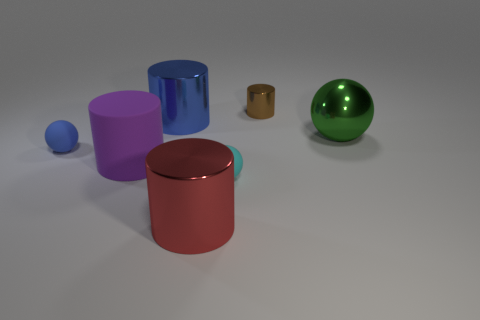Subtract all blue cylinders. How many cylinders are left? 3 Subtract all gray cylinders. Subtract all yellow cubes. How many cylinders are left? 4 Add 3 big gray metallic objects. How many objects exist? 10 Subtract all balls. How many objects are left? 4 Add 4 large blue rubber spheres. How many large blue rubber spheres exist? 4 Subtract 0 green cubes. How many objects are left? 7 Subtract all blue cylinders. Subtract all large things. How many objects are left? 2 Add 2 large blue metal objects. How many large blue metal objects are left? 3 